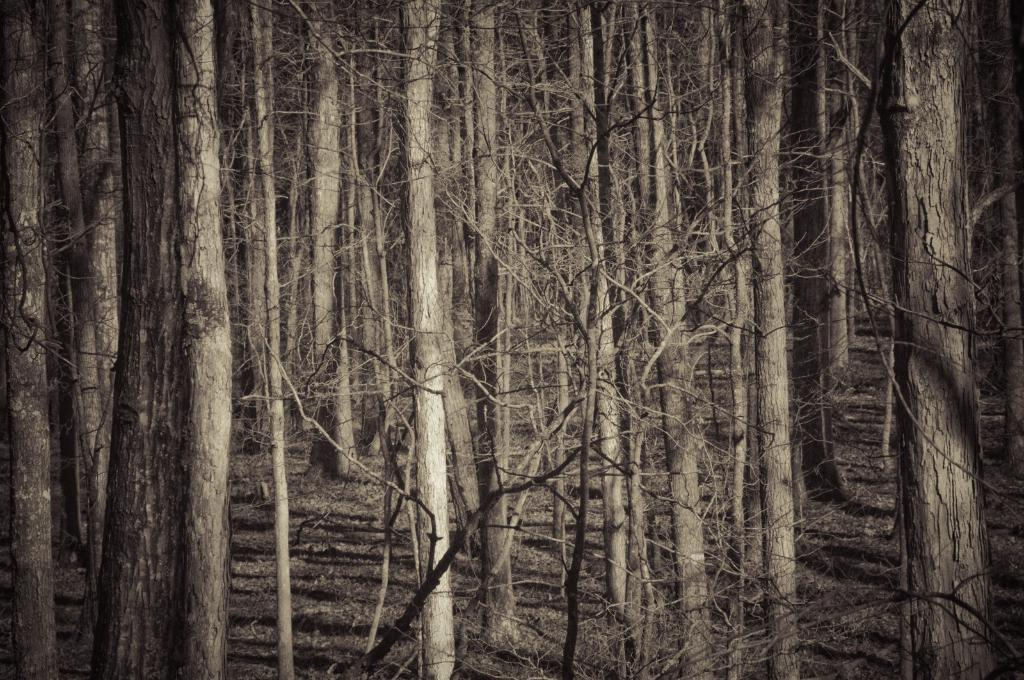What type of vegetation can be seen in the image? There are trees in the image. Can you describe the condition of the stems in the image? There are dry stems with no leaves in the image. What type of creature can be seen interacting with the lettuce on the stove in the image? There is no creature, lettuce, or stove present in the image. 